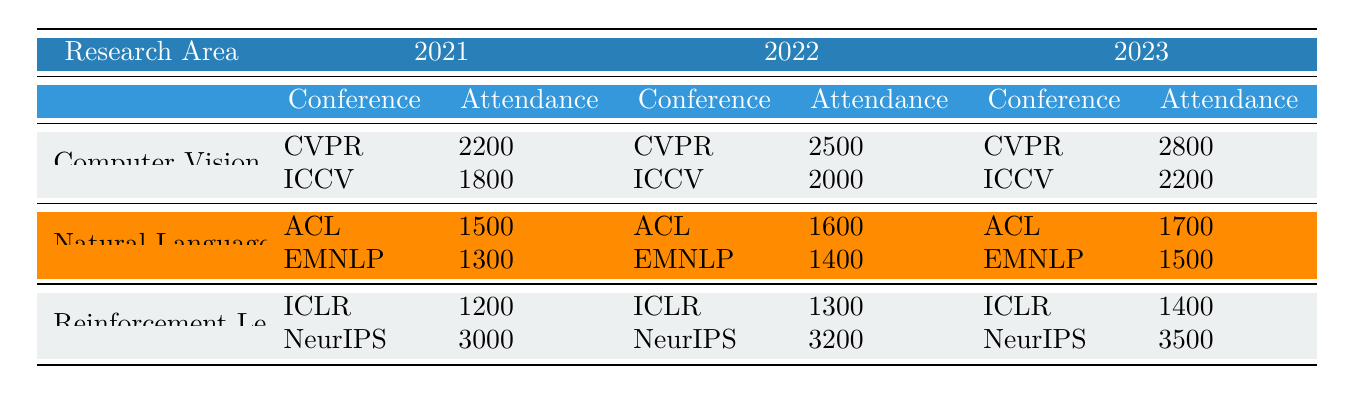What was the attendance at CVPR in 2022? The table shows that the attendance for CVPR in 2022 is listed under the Computer Vision category, which indicates it was 2500.
Answer: 2500 Which conference had the highest attendance in 2023? To find the highest attendance in 2023, we look at all conferences listed under that year: CVPR (2800), ICCV (2200), ACL (1700), EMNLP (1500), ICLR (1400), and NeurIPS (3500). NeurIPS has the highest attendance at 3500.
Answer: NeurIPS How much did attendance increase for ICLR from 2021 to 2023? The attendance for ICLR in 2021 is 1200 and in 2023 it is 1400. We calculate the increase as 1400 - 1200 = 200.
Answer: 200 Is the attendance at ACL in 2022 greater than the attendance at EMNLP in 2021? The attendance for ACL in 2022 is 1600 and for EMNLP in 2021 it is 1300. Since 1600 is greater than 1300, the statement is true.
Answer: Yes What is the total attendance for all Reinforcement Learning conferences in 2022? The total attendance for Reinforcement Learning conferences in 2022 includes ICLR (1300) and NeurIPS (3200). We sum them up: 1300 + 3200 = 4500.
Answer: 4500 Which research area had the lowest total attendance across all years? First, we need to find the total attendance for each research area across all three years. For Computer Vision: (2200 + 2500 + 2800 = 7500), for Natural Language Processing: (1500 + 1600 + 1700 = 4800), and for Reinforcement Learning: (1200 + 1300 + 1400 + 3000 + 3200 + 3500 = 12400). The lowest total attendance is for Natural Language Processing at 4800.
Answer: Natural Language Processing What was the average attendance for all conferences in 2021? The total attendance for all conferences in 2021 includes CVPR (2200), ICCV (1800), ACL (1500), EMNLP (1300), ICLR (1200), and NeurIPS (3000). Summing these values gives us 25000. There are 6 conferences, so the average is 25000/6 = 2083.33.
Answer: 2083.33 Was the attendance for EMNLP in 2023 higher than that in 2021? The attendance for EMNLP in 2023 is 1500 and in 2021, it was 1300. Since 1500 is greater than 1300, the answer is yes.
Answer: Yes What is the attendance difference between NeurIPS in 2022 and 2023? The attendance for NeurIPS in 2022 is 3200 and in 2023 it is 3500. The difference is calculated as 3500 - 3200 = 300.
Answer: 300 